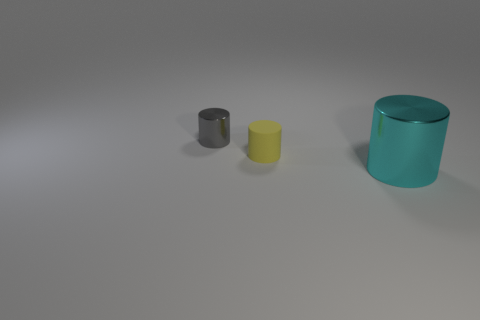Is there a small purple cylinder that has the same material as the yellow cylinder?
Ensure brevity in your answer.  No. Is the number of tiny gray shiny things greater than the number of metal things?
Make the answer very short. No. Does the cyan cylinder have the same material as the tiny gray cylinder?
Your answer should be very brief. Yes. What number of rubber objects are tiny things or cyan cylinders?
Offer a terse response. 1. The matte thing that is the same size as the gray cylinder is what color?
Offer a very short reply. Yellow. How many big things have the same shape as the tiny rubber thing?
Provide a short and direct response. 1. How many spheres are big shiny objects or small gray things?
Your answer should be compact. 0. Do the object left of the yellow object and the metal thing in front of the tiny gray metal object have the same shape?
Your answer should be very brief. Yes. What is the small yellow thing made of?
Offer a terse response. Rubber. What number of yellow things are the same size as the gray object?
Provide a succinct answer. 1. 